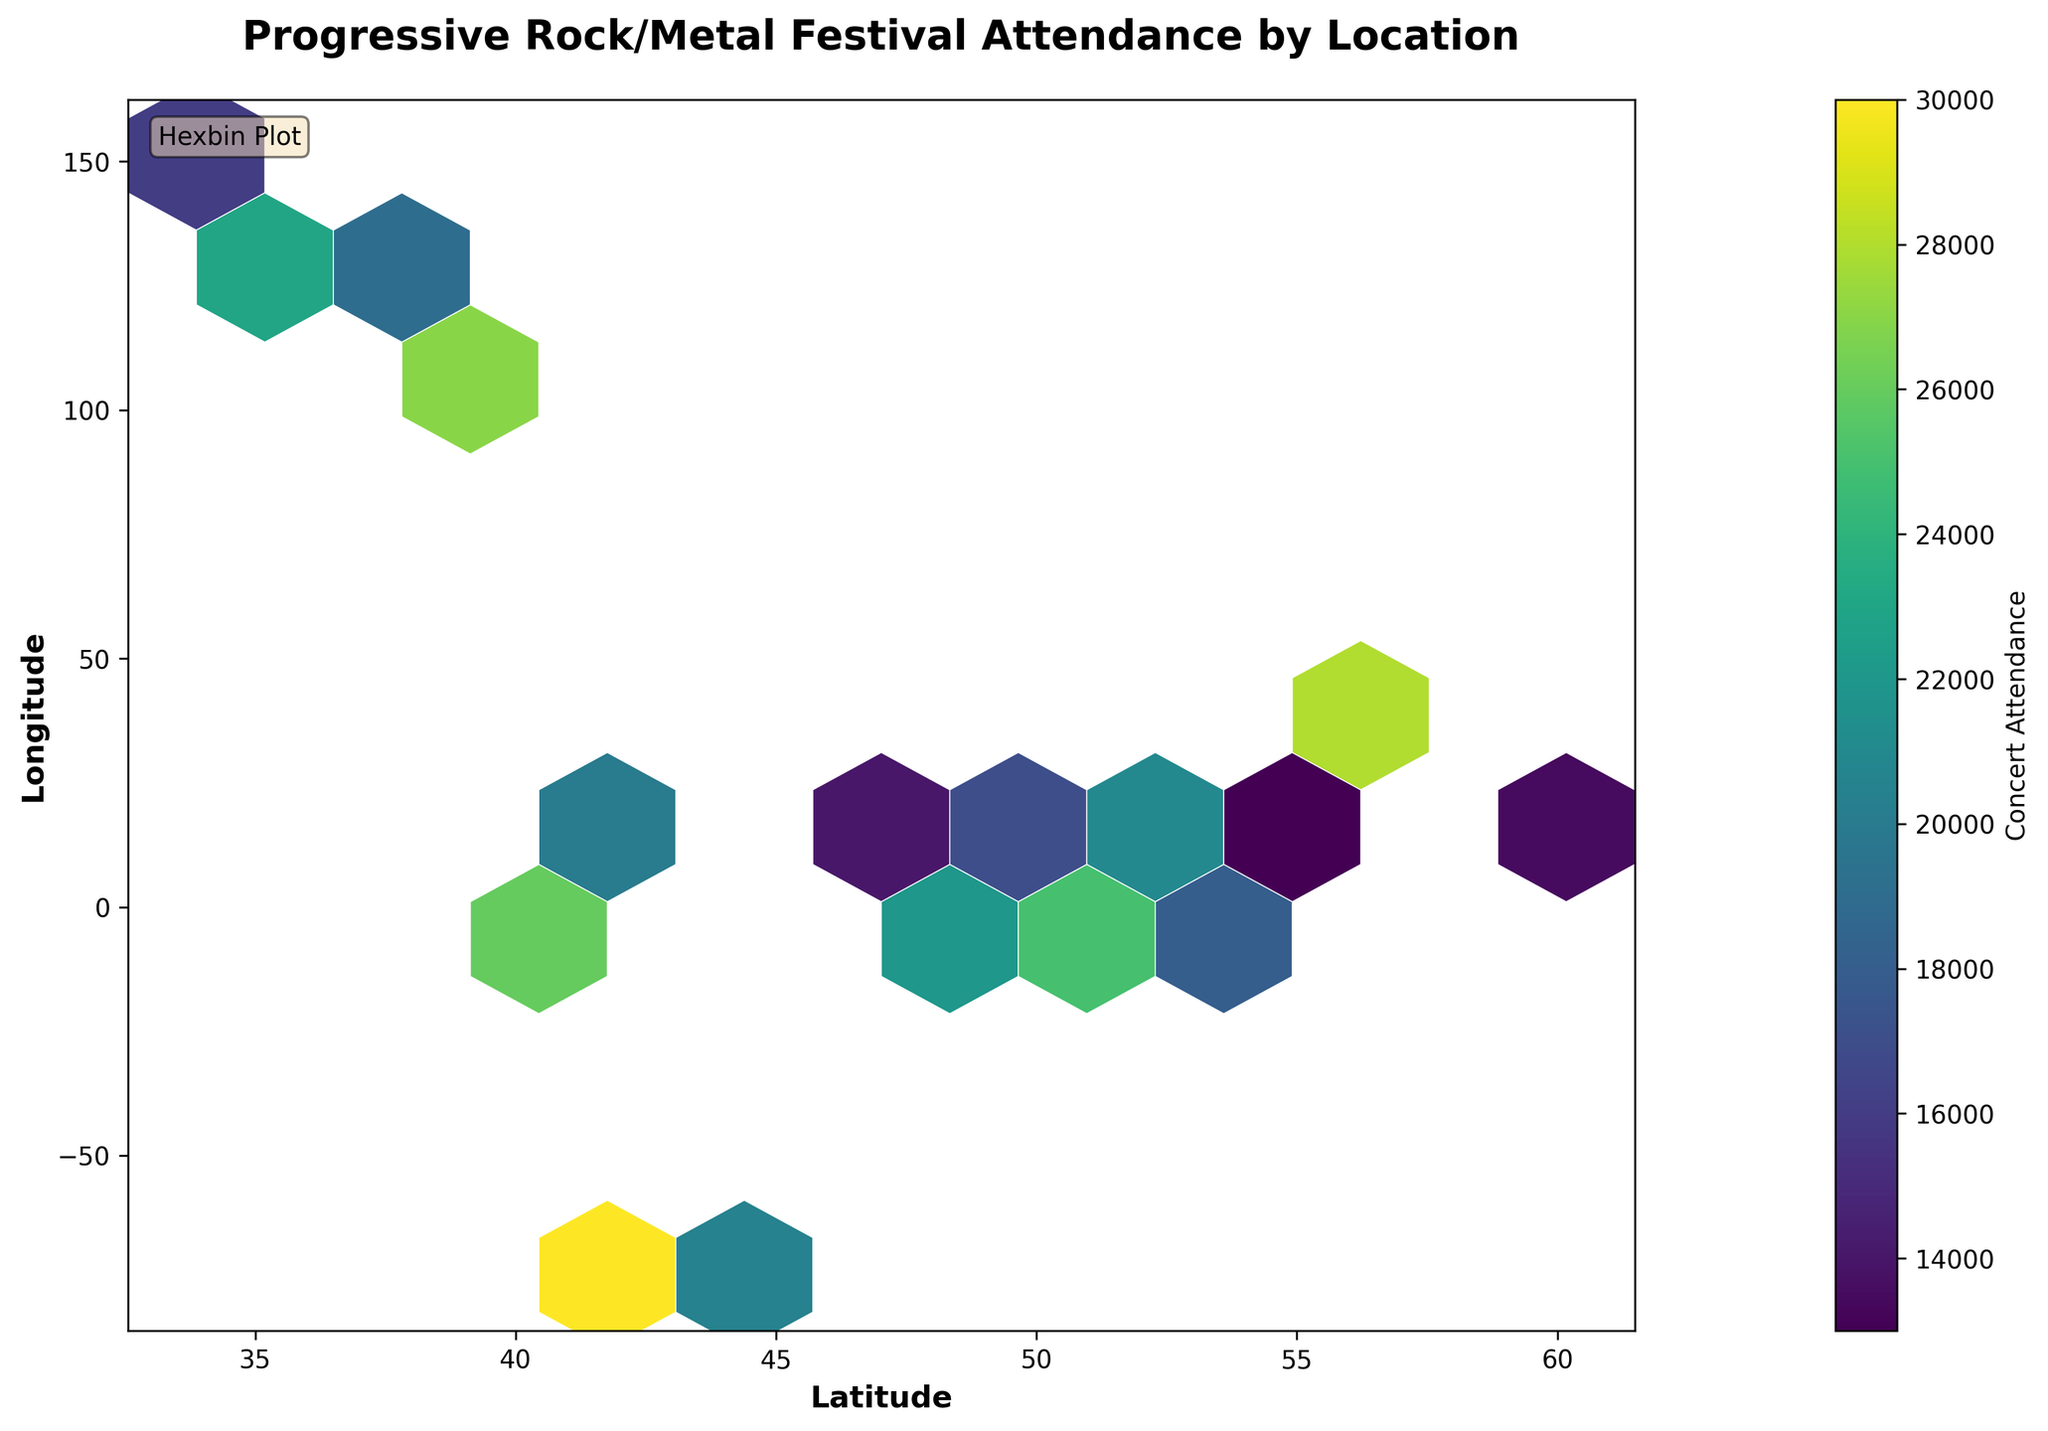What is the title of the plot? The title of the plot is usually displayed at the top of the figure and provides a summary of what the plot represents. In this case, it should be listed at the top of the hexbin plot.
Answer: Progressive Rock/Metal Festival Attendance by Location What do the colors in the hexbin plot represent? The colors in a hexbin plot typically indicate the intensity or concentration of a variable within the hexagon bins. In this case, the color represents the concert attendance figures. Darker colors usually indicate higher values.
Answer: Concert Attendance Figures How many hexagon bins are there in the plot? To find the number of hexagon bins, you count the individual hexagon shapes displayed on the plot. The total number depends on the data distribution and the "gridsize" parameter settings.
Answer: 10 What does the color bar indicate on the side of the hexbin plot? The color bar, which is often placed next to the plot, acts as a legend for the hexbin colors, showing the mapping between color intensity and the numerical values of concert attendance.
Answer: The mapping between color and concert attendance What are the x and y-axis labels? The x and y-axis labels are usually displayed along the respective axes and indicate the data's dimensions being plotted. In this case, they should be labeled as specified.
Answer: Latitude and Longitude Which location has the highest concert attendance figure? To identify this, check the hexagon with the darkest color on the plot. The center coordinates of this hexagon will indicate the geographic location with the highest attendance. Based on the data, this would be New York City (Latitude: 40.7128, Longitude: -74.0060).
Answer: New York City Compare the concert attendance figures between New York City and Rome. Which one is higher and by how much? By evaluating the color intensity of the hexagons situated around the coordinates for New York City and Rome, and consulting the color bar, we see that New York City has an attendance of 30,000, whereas Rome has 20,000, thus New York City has higher attendance by 10,000.
Answer: New York City (30,000 - 20,000 = 10,000 higher) Which city has the lowest concert attendance, and what is the value? Identify the hexagon with the lightest color and matching coordinates to find the city. According to the data, Helsinki (Latitude: 60.1699, Longitude: 24.9384) has the lowest attendance figure.
Answer: Helsinki with 12,000 How does the concert attendance figure for London compare to Tokyo? Referring to the color intensity and matching it to the respective hexagons in the plot, we can compare the attendance figures. London has an attendance of 25,000 while Tokyo has 23,000. London has a higher attendance.
Answer: London (25,000 vs. 23,000 for Tokyo) Calculate the average concert attendance across all cities provided in the dataset. Sum the concert attendance for all locations and divide by the number of locations. Total attendance is 421,000 for 20 locations (25000 + 22000 + 30000 + 18000 + 20000 + 15000 + 17000 + 28000 + 23000 + 19000 + 21000 + 16000 + 24000 + 14000 + 26000 + 27000 + 13000 + 12000 + 18000 + 20000). The average attendance is 421,000 / 20.
Answer: 21,050 